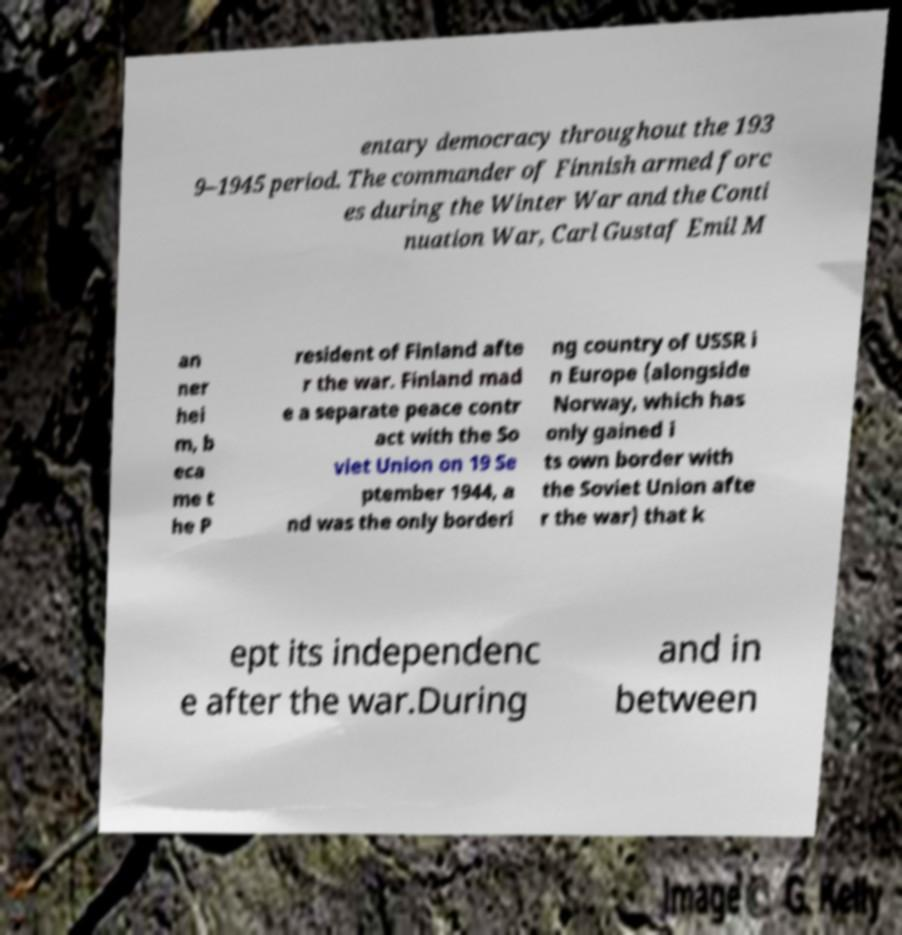There's text embedded in this image that I need extracted. Can you transcribe it verbatim? entary democracy throughout the 193 9–1945 period. The commander of Finnish armed forc es during the Winter War and the Conti nuation War, Carl Gustaf Emil M an ner hei m, b eca me t he P resident of Finland afte r the war. Finland mad e a separate peace contr act with the So viet Union on 19 Se ptember 1944, a nd was the only borderi ng country of USSR i n Europe (alongside Norway, which has only gained i ts own border with the Soviet Union afte r the war) that k ept its independenc e after the war.During and in between 